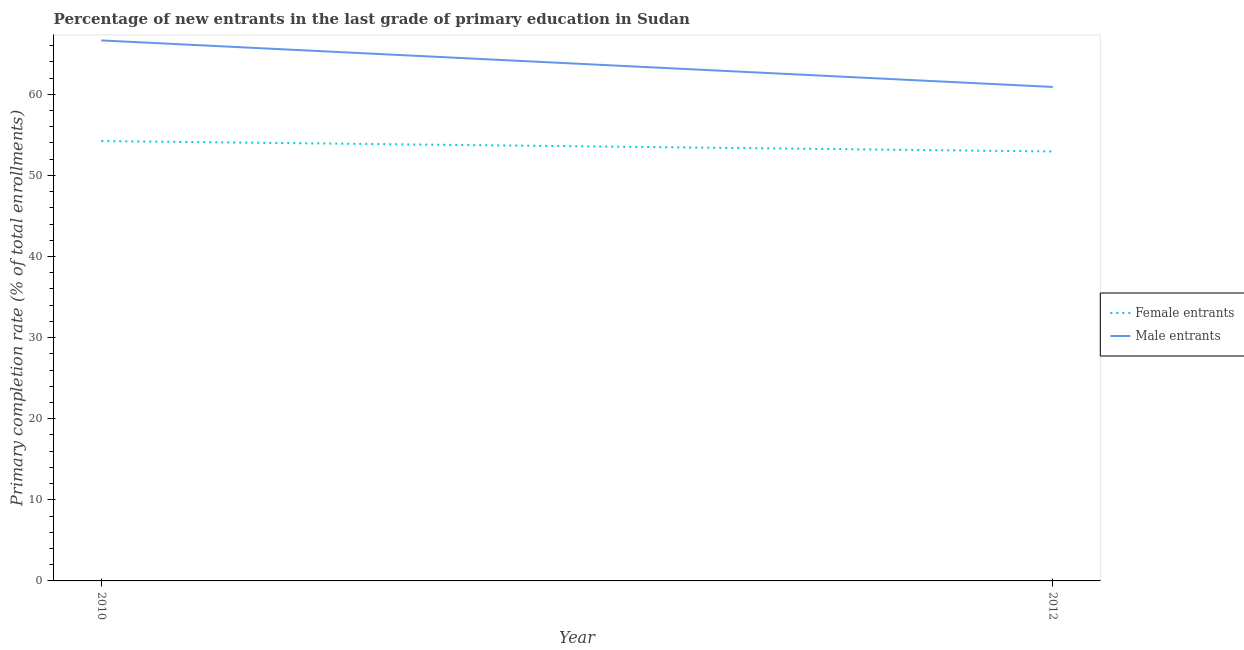How many different coloured lines are there?
Offer a very short reply. 2. What is the primary completion rate of female entrants in 2012?
Give a very brief answer. 52.94. Across all years, what is the maximum primary completion rate of male entrants?
Offer a terse response. 66.63. Across all years, what is the minimum primary completion rate of female entrants?
Your response must be concise. 52.94. What is the total primary completion rate of male entrants in the graph?
Provide a short and direct response. 127.53. What is the difference between the primary completion rate of female entrants in 2010 and that in 2012?
Offer a very short reply. 1.28. What is the difference between the primary completion rate of female entrants in 2010 and the primary completion rate of male entrants in 2012?
Offer a terse response. -6.67. What is the average primary completion rate of male entrants per year?
Provide a succinct answer. 63.77. In the year 2012, what is the difference between the primary completion rate of male entrants and primary completion rate of female entrants?
Ensure brevity in your answer.  7.95. What is the ratio of the primary completion rate of male entrants in 2010 to that in 2012?
Keep it short and to the point. 1.09. Is the primary completion rate of male entrants in 2010 less than that in 2012?
Your answer should be very brief. No. Does the primary completion rate of male entrants monotonically increase over the years?
Provide a short and direct response. No. Is the primary completion rate of male entrants strictly greater than the primary completion rate of female entrants over the years?
Give a very brief answer. Yes. How many lines are there?
Ensure brevity in your answer.  2. What is the difference between two consecutive major ticks on the Y-axis?
Your answer should be very brief. 10. Does the graph contain grids?
Your answer should be compact. No. How are the legend labels stacked?
Provide a succinct answer. Vertical. What is the title of the graph?
Your answer should be very brief. Percentage of new entrants in the last grade of primary education in Sudan. Does "Private funds" appear as one of the legend labels in the graph?
Your answer should be compact. No. What is the label or title of the Y-axis?
Make the answer very short. Primary completion rate (% of total enrollments). What is the Primary completion rate (% of total enrollments) of Female entrants in 2010?
Provide a short and direct response. 54.23. What is the Primary completion rate (% of total enrollments) of Male entrants in 2010?
Make the answer very short. 66.63. What is the Primary completion rate (% of total enrollments) of Female entrants in 2012?
Your response must be concise. 52.94. What is the Primary completion rate (% of total enrollments) in Male entrants in 2012?
Offer a terse response. 60.9. Across all years, what is the maximum Primary completion rate (% of total enrollments) of Female entrants?
Offer a terse response. 54.23. Across all years, what is the maximum Primary completion rate (% of total enrollments) of Male entrants?
Your response must be concise. 66.63. Across all years, what is the minimum Primary completion rate (% of total enrollments) in Female entrants?
Keep it short and to the point. 52.94. Across all years, what is the minimum Primary completion rate (% of total enrollments) in Male entrants?
Make the answer very short. 60.9. What is the total Primary completion rate (% of total enrollments) in Female entrants in the graph?
Keep it short and to the point. 107.17. What is the total Primary completion rate (% of total enrollments) in Male entrants in the graph?
Your response must be concise. 127.53. What is the difference between the Primary completion rate (% of total enrollments) of Female entrants in 2010 and that in 2012?
Keep it short and to the point. 1.28. What is the difference between the Primary completion rate (% of total enrollments) of Male entrants in 2010 and that in 2012?
Ensure brevity in your answer.  5.74. What is the difference between the Primary completion rate (% of total enrollments) in Female entrants in 2010 and the Primary completion rate (% of total enrollments) in Male entrants in 2012?
Your answer should be compact. -6.67. What is the average Primary completion rate (% of total enrollments) of Female entrants per year?
Offer a very short reply. 53.59. What is the average Primary completion rate (% of total enrollments) of Male entrants per year?
Ensure brevity in your answer.  63.77. In the year 2010, what is the difference between the Primary completion rate (% of total enrollments) in Female entrants and Primary completion rate (% of total enrollments) in Male entrants?
Your answer should be very brief. -12.41. In the year 2012, what is the difference between the Primary completion rate (% of total enrollments) of Female entrants and Primary completion rate (% of total enrollments) of Male entrants?
Your response must be concise. -7.95. What is the ratio of the Primary completion rate (% of total enrollments) of Female entrants in 2010 to that in 2012?
Provide a succinct answer. 1.02. What is the ratio of the Primary completion rate (% of total enrollments) of Male entrants in 2010 to that in 2012?
Make the answer very short. 1.09. What is the difference between the highest and the second highest Primary completion rate (% of total enrollments) of Female entrants?
Provide a succinct answer. 1.28. What is the difference between the highest and the second highest Primary completion rate (% of total enrollments) in Male entrants?
Provide a short and direct response. 5.74. What is the difference between the highest and the lowest Primary completion rate (% of total enrollments) of Female entrants?
Give a very brief answer. 1.28. What is the difference between the highest and the lowest Primary completion rate (% of total enrollments) of Male entrants?
Your answer should be compact. 5.74. 